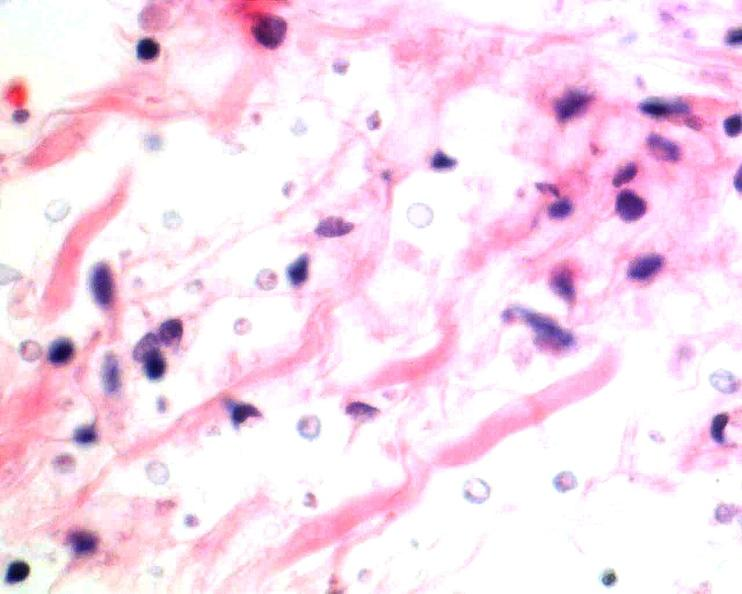does spinal column show brain, cryptococcal meningitis, he?
Answer the question using a single word or phrase. No 